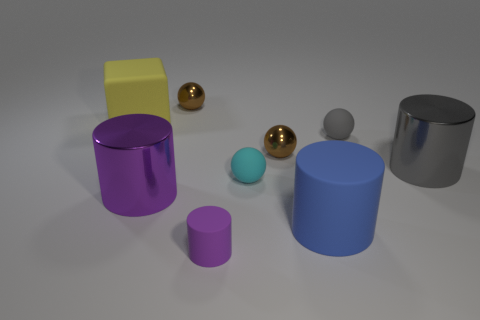Subtract all purple cylinders. How many were subtracted if there are1purple cylinders left? 1 Add 1 brown things. How many objects exist? 10 Subtract all yellow balls. Subtract all red cylinders. How many balls are left? 4 Subtract all cubes. How many objects are left? 8 Add 5 purple shiny things. How many purple shiny things exist? 6 Subtract 0 purple balls. How many objects are left? 9 Subtract all cyan matte cubes. Subtract all large cylinders. How many objects are left? 6 Add 1 big blue cylinders. How many big blue cylinders are left? 2 